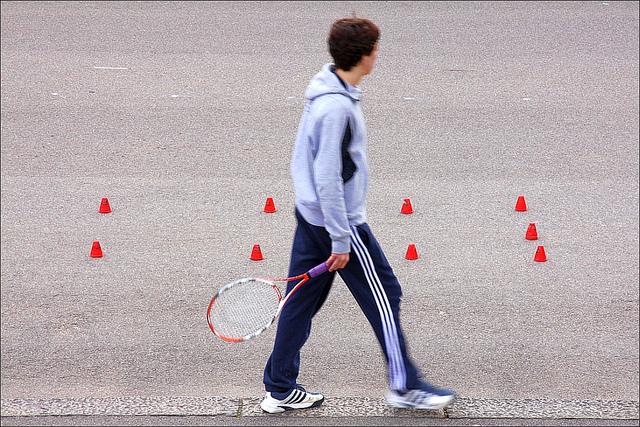What game is the person playing?
Concise answer only. Tennis. Why is the person in motion?
Give a very brief answer. Walking. Are the red cones equal?
Concise answer only. No. 